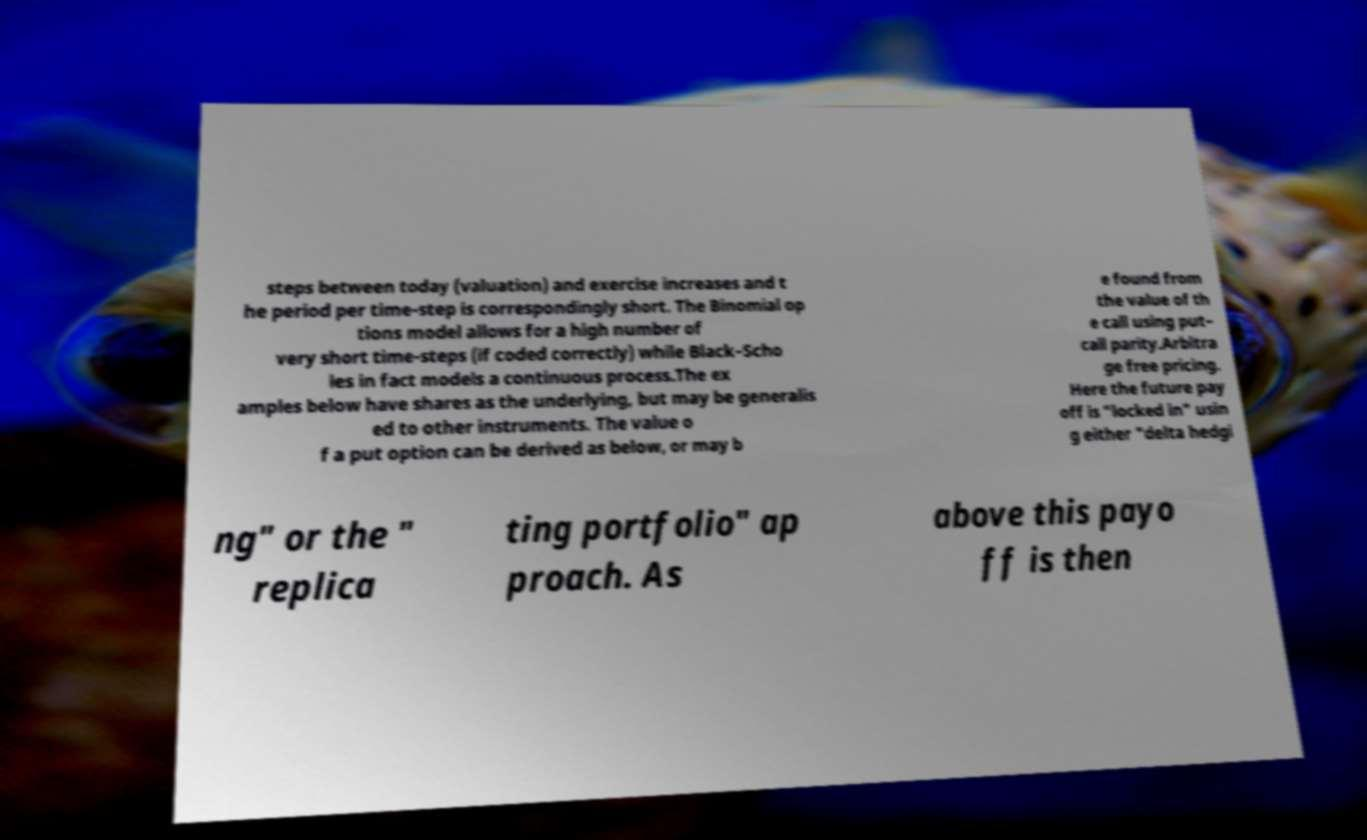Can you read and provide the text displayed in the image?This photo seems to have some interesting text. Can you extract and type it out for me? steps between today (valuation) and exercise increases and t he period per time-step is correspondingly short. The Binomial op tions model allows for a high number of very short time-steps (if coded correctly) while Black–Scho les in fact models a continuous process.The ex amples below have shares as the underlying, but may be generalis ed to other instruments. The value o f a put option can be derived as below, or may b e found from the value of th e call using put– call parity.Arbitra ge free pricing. Here the future pay off is "locked in" usin g either "delta hedgi ng" or the " replica ting portfolio" ap proach. As above this payo ff is then 